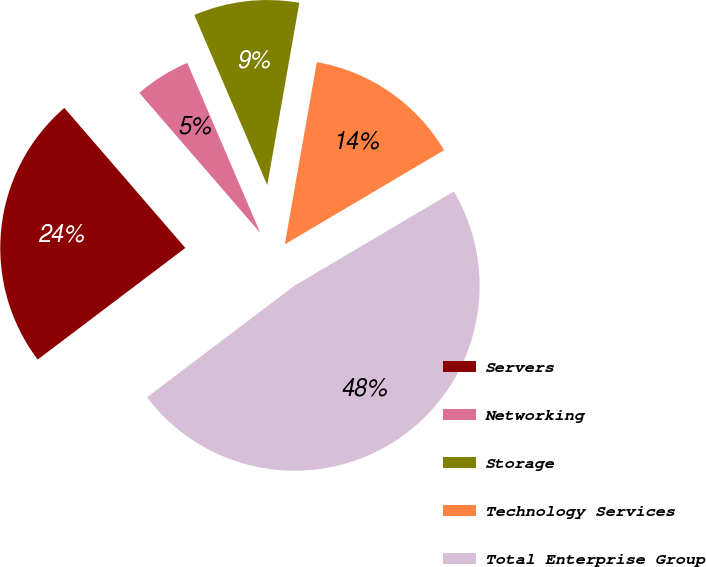Convert chart to OTSL. <chart><loc_0><loc_0><loc_500><loc_500><pie_chart><fcel>Servers<fcel>Networking<fcel>Storage<fcel>Technology Services<fcel>Total Enterprise Group<nl><fcel>23.96%<fcel>4.89%<fcel>9.22%<fcel>13.73%<fcel>48.19%<nl></chart> 